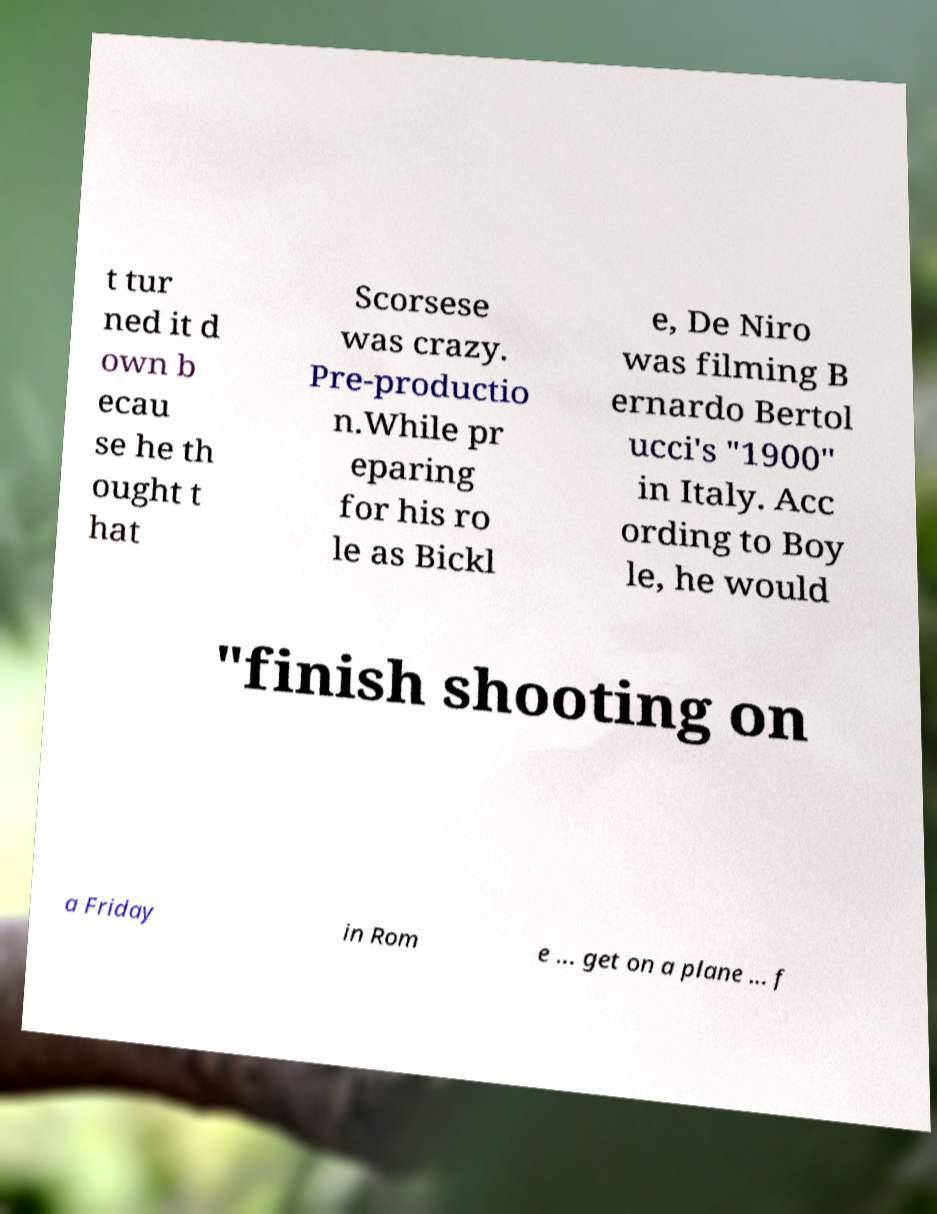Can you accurately transcribe the text from the provided image for me? t tur ned it d own b ecau se he th ought t hat Scorsese was crazy. Pre-productio n.While pr eparing for his ro le as Bickl e, De Niro was filming B ernardo Bertol ucci's "1900" in Italy. Acc ording to Boy le, he would "finish shooting on a Friday in Rom e ... get on a plane ... f 